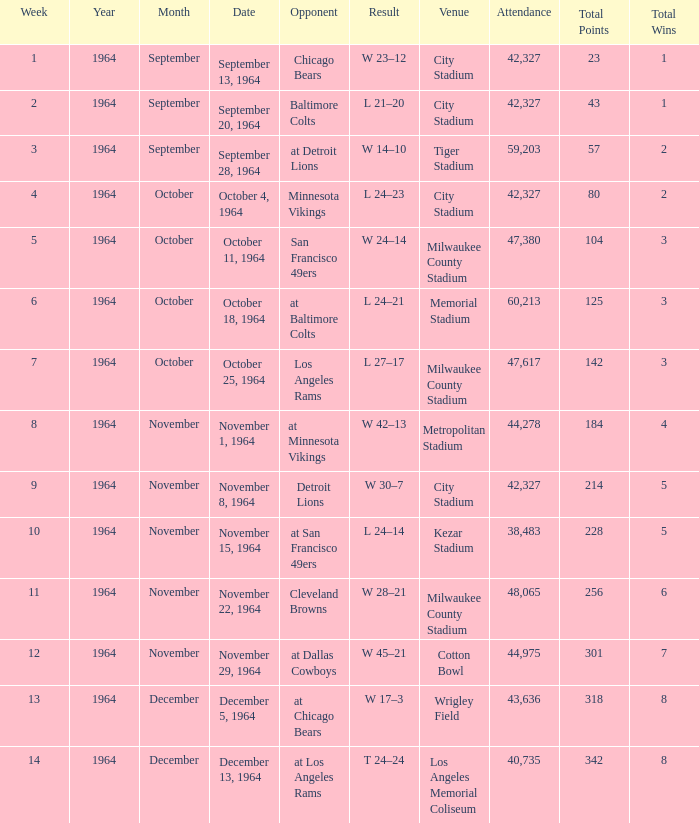What venue held that game with a result of l 24–14? Kezar Stadium. 